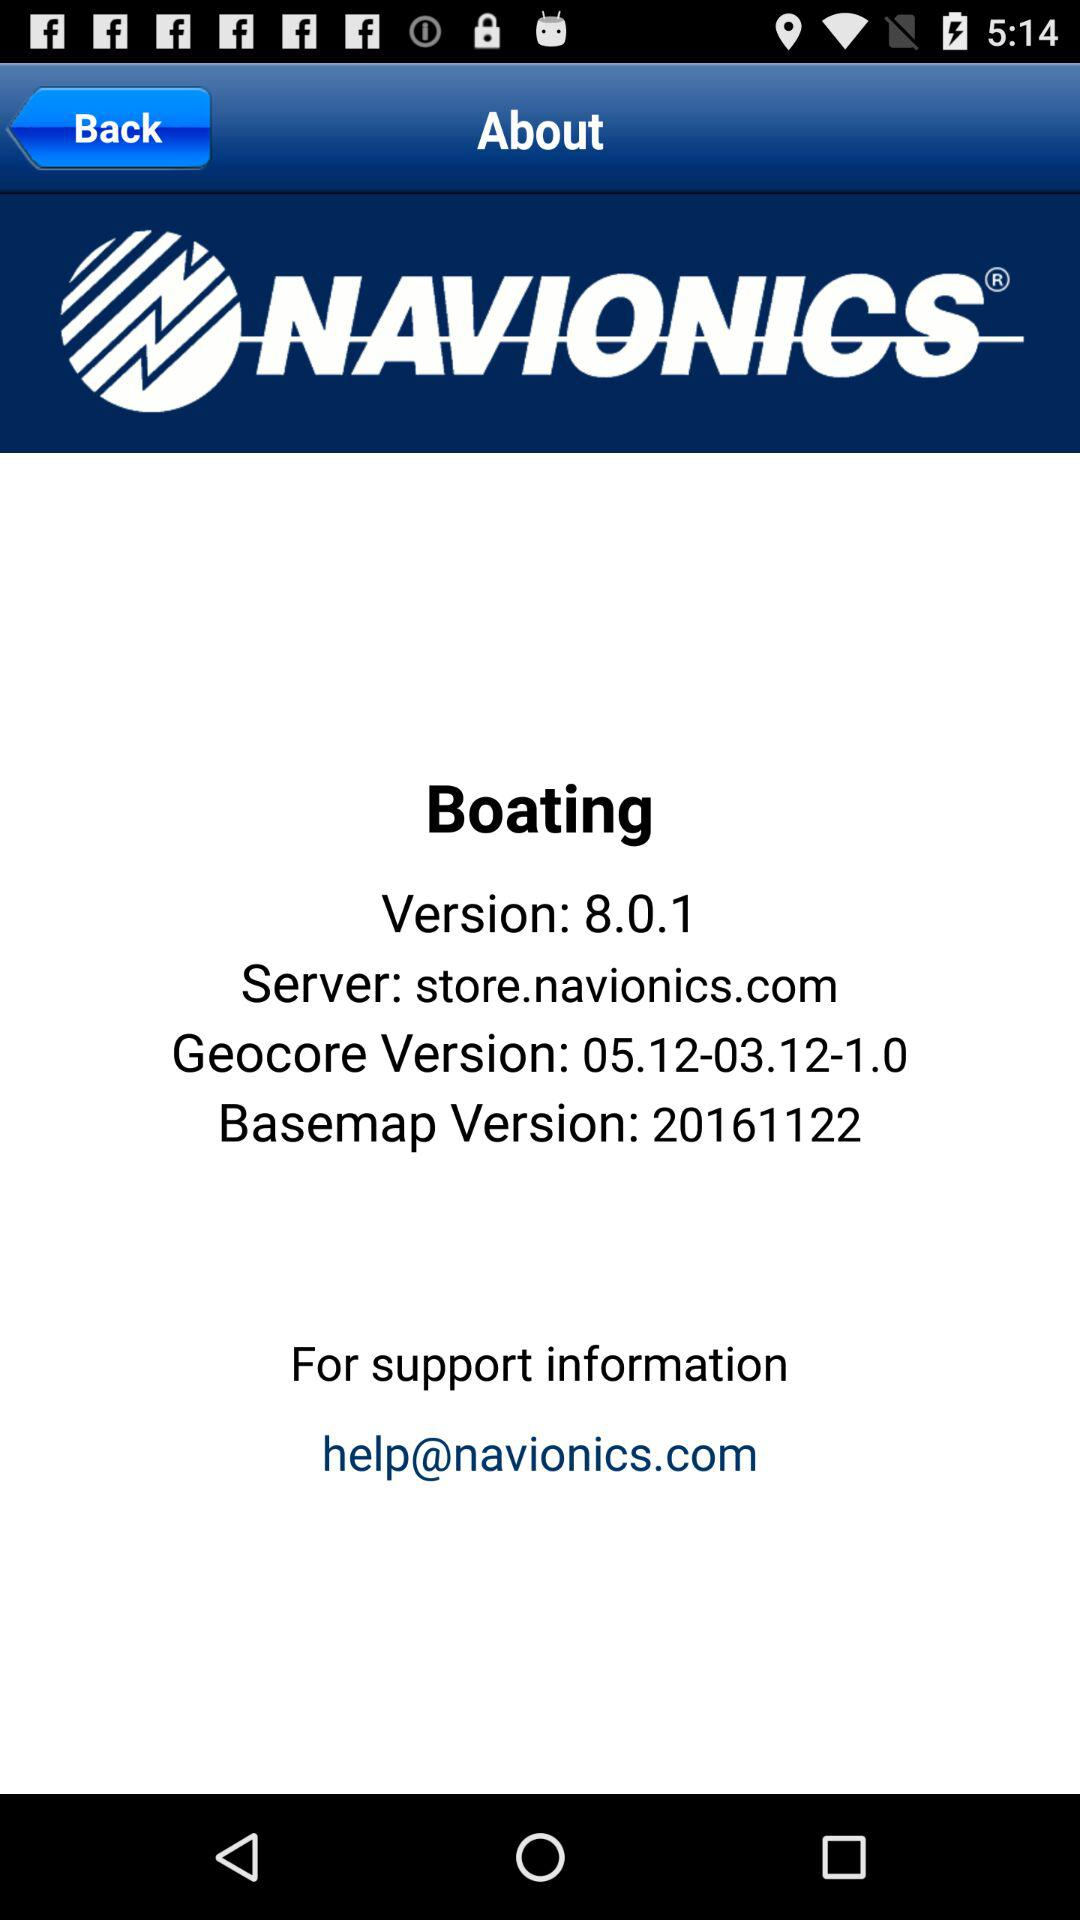What's the official site mail address for information support? The official site mail address is "help@navionics.com". 